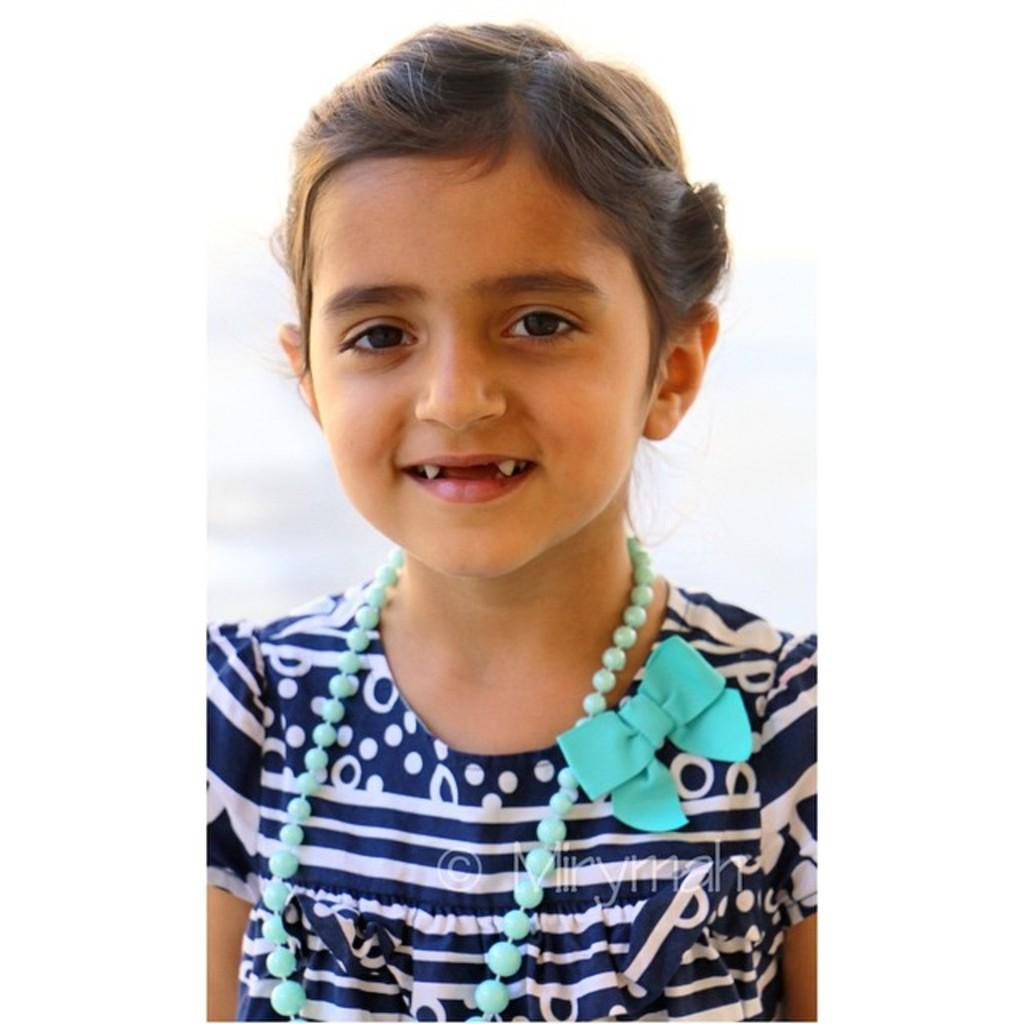What is the main subject of the image? The main subject of the image is a small girl. What is the girl wearing in the image? The girl is wearing a blue top. What is the girl's facial expression in the image? The girl is smiling in the image. What is the girl doing in the image? The girl is posing for the camera. What is the color of the background in the image? The background of the image is white. Can you see a nest in the image? There is no nest present in the image. What answer is the girl providing in the image? The girl is not providing an answer in the image; she is posing for the camera and smiling. 